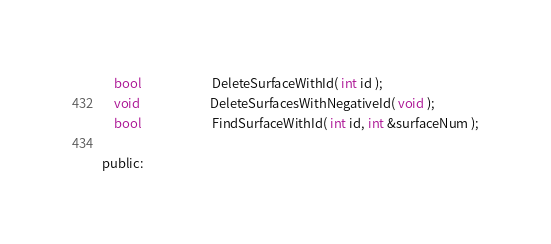<code> <loc_0><loc_0><loc_500><loc_500><_C_>	bool						DeleteSurfaceWithId( int id );
	void						DeleteSurfacesWithNegativeId( void );
	bool						FindSurfaceWithId( int id, int &surfaceNum );

public:</code> 